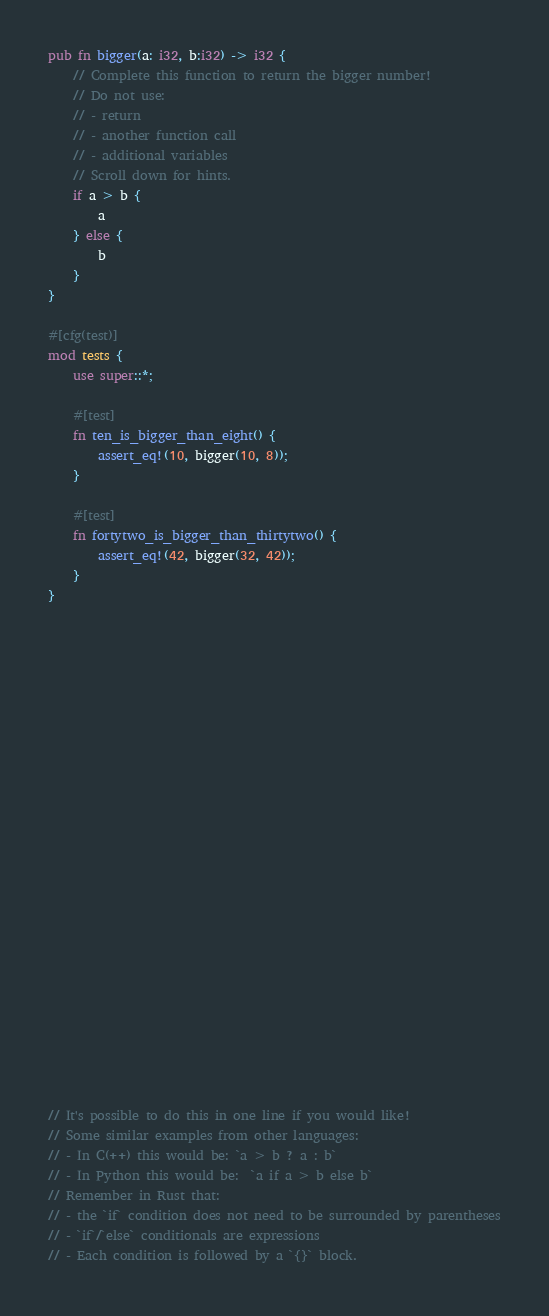<code> <loc_0><loc_0><loc_500><loc_500><_Rust_>pub fn bigger(a: i32, b:i32) -> i32 {
    // Complete this function to return the bigger number!
    // Do not use:
    // - return
    // - another function call
    // - additional variables
    // Scroll down for hints.
    if a > b {
        a
    } else {
        b
    }
}

#[cfg(test)]
mod tests {
    use super::*;

    #[test]
    fn ten_is_bigger_than_eight() {
        assert_eq!(10, bigger(10, 8));
    }

    #[test]
    fn fortytwo_is_bigger_than_thirtytwo() {
        assert_eq!(42, bigger(32, 42));
    }
}

























// It's possible to do this in one line if you would like!
// Some similar examples from other languages:
// - In C(++) this would be: `a > b ? a : b`
// - In Python this would be:  `a if a > b else b`
// Remember in Rust that:
// - the `if` condition does not need to be surrounded by parentheses
// - `if`/`else` conditionals are expressions
// - Each condition is followed by a `{}` block.
</code> 